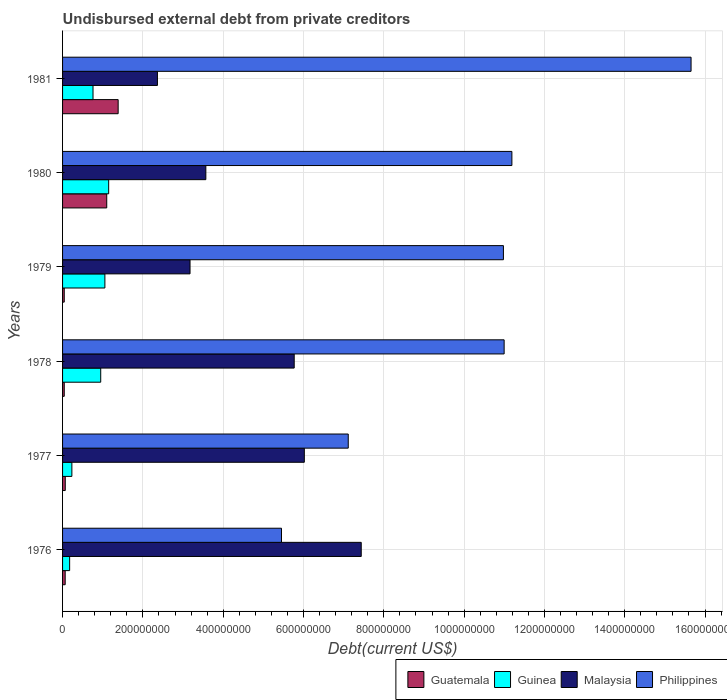Are the number of bars on each tick of the Y-axis equal?
Your response must be concise. Yes. What is the label of the 4th group of bars from the top?
Your answer should be compact. 1978. What is the total debt in Philippines in 1980?
Keep it short and to the point. 1.12e+09. Across all years, what is the maximum total debt in Guinea?
Your answer should be compact. 1.15e+08. Across all years, what is the minimum total debt in Guinea?
Your answer should be compact. 1.76e+07. What is the total total debt in Malaysia in the graph?
Keep it short and to the point. 2.83e+09. What is the difference between the total debt in Malaysia in 1977 and that in 1978?
Your response must be concise. 2.52e+07. What is the difference between the total debt in Guatemala in 1980 and the total debt in Malaysia in 1977?
Ensure brevity in your answer.  -4.92e+08. What is the average total debt in Guinea per year?
Offer a very short reply. 7.20e+07. In the year 1979, what is the difference between the total debt in Malaysia and total debt in Philippines?
Give a very brief answer. -7.80e+08. In how many years, is the total debt in Guatemala greater than 1080000000 US$?
Your answer should be compact. 0. What is the ratio of the total debt in Guatemala in 1976 to that in 1981?
Offer a very short reply. 0.05. Is the total debt in Malaysia in 1976 less than that in 1981?
Your answer should be very brief. No. What is the difference between the highest and the second highest total debt in Philippines?
Provide a short and direct response. 4.46e+08. What is the difference between the highest and the lowest total debt in Guatemala?
Provide a succinct answer. 1.34e+08. In how many years, is the total debt in Guatemala greater than the average total debt in Guatemala taken over all years?
Provide a short and direct response. 2. Is it the case that in every year, the sum of the total debt in Guinea and total debt in Guatemala is greater than the sum of total debt in Philippines and total debt in Malaysia?
Your answer should be very brief. No. What does the 3rd bar from the top in 1980 represents?
Give a very brief answer. Guinea. What does the 3rd bar from the bottom in 1976 represents?
Offer a very short reply. Malaysia. Is it the case that in every year, the sum of the total debt in Malaysia and total debt in Guatemala is greater than the total debt in Philippines?
Offer a very short reply. No. How many bars are there?
Offer a terse response. 24. Does the graph contain grids?
Provide a succinct answer. Yes. How many legend labels are there?
Offer a very short reply. 4. What is the title of the graph?
Provide a succinct answer. Undisbursed external debt from private creditors. Does "Yemen, Rep." appear as one of the legend labels in the graph?
Your response must be concise. No. What is the label or title of the X-axis?
Your response must be concise. Debt(current US$). What is the Debt(current US$) in Guatemala in 1976?
Provide a succinct answer. 6.51e+06. What is the Debt(current US$) of Guinea in 1976?
Offer a very short reply. 1.76e+07. What is the Debt(current US$) of Malaysia in 1976?
Provide a short and direct response. 7.44e+08. What is the Debt(current US$) in Philippines in 1976?
Provide a succinct answer. 5.45e+08. What is the Debt(current US$) in Guatemala in 1977?
Offer a terse response. 6.72e+06. What is the Debt(current US$) of Guinea in 1977?
Give a very brief answer. 2.32e+07. What is the Debt(current US$) in Malaysia in 1977?
Your response must be concise. 6.02e+08. What is the Debt(current US$) of Philippines in 1977?
Keep it short and to the point. 7.11e+08. What is the Debt(current US$) of Guatemala in 1978?
Keep it short and to the point. 4.18e+06. What is the Debt(current US$) in Guinea in 1978?
Give a very brief answer. 9.50e+07. What is the Debt(current US$) in Malaysia in 1978?
Make the answer very short. 5.77e+08. What is the Debt(current US$) of Philippines in 1978?
Keep it short and to the point. 1.10e+09. What is the Debt(current US$) of Guatemala in 1979?
Your answer should be very brief. 4.18e+06. What is the Debt(current US$) of Guinea in 1979?
Ensure brevity in your answer.  1.05e+08. What is the Debt(current US$) in Malaysia in 1979?
Your response must be concise. 3.17e+08. What is the Debt(current US$) of Philippines in 1979?
Give a very brief answer. 1.10e+09. What is the Debt(current US$) of Guatemala in 1980?
Your answer should be compact. 1.10e+08. What is the Debt(current US$) of Guinea in 1980?
Offer a very short reply. 1.15e+08. What is the Debt(current US$) of Malaysia in 1980?
Your answer should be compact. 3.57e+08. What is the Debt(current US$) in Philippines in 1980?
Offer a terse response. 1.12e+09. What is the Debt(current US$) in Guatemala in 1981?
Your answer should be compact. 1.38e+08. What is the Debt(current US$) in Guinea in 1981?
Provide a succinct answer. 7.58e+07. What is the Debt(current US$) of Malaysia in 1981?
Give a very brief answer. 2.36e+08. What is the Debt(current US$) in Philippines in 1981?
Your response must be concise. 1.57e+09. Across all years, what is the maximum Debt(current US$) of Guatemala?
Offer a terse response. 1.38e+08. Across all years, what is the maximum Debt(current US$) in Guinea?
Your answer should be very brief. 1.15e+08. Across all years, what is the maximum Debt(current US$) of Malaysia?
Your response must be concise. 7.44e+08. Across all years, what is the maximum Debt(current US$) in Philippines?
Offer a very short reply. 1.57e+09. Across all years, what is the minimum Debt(current US$) of Guatemala?
Offer a terse response. 4.18e+06. Across all years, what is the minimum Debt(current US$) of Guinea?
Offer a very short reply. 1.76e+07. Across all years, what is the minimum Debt(current US$) in Malaysia?
Provide a short and direct response. 2.36e+08. Across all years, what is the minimum Debt(current US$) of Philippines?
Your answer should be compact. 5.45e+08. What is the total Debt(current US$) in Guatemala in the graph?
Offer a terse response. 2.70e+08. What is the total Debt(current US$) in Guinea in the graph?
Your response must be concise. 4.32e+08. What is the total Debt(current US$) of Malaysia in the graph?
Provide a succinct answer. 2.83e+09. What is the total Debt(current US$) in Philippines in the graph?
Your response must be concise. 6.14e+09. What is the difference between the Debt(current US$) of Guatemala in 1976 and that in 1977?
Offer a very short reply. -2.15e+05. What is the difference between the Debt(current US$) in Guinea in 1976 and that in 1977?
Keep it short and to the point. -5.54e+06. What is the difference between the Debt(current US$) in Malaysia in 1976 and that in 1977?
Your answer should be compact. 1.42e+08. What is the difference between the Debt(current US$) in Philippines in 1976 and that in 1977?
Your answer should be compact. -1.66e+08. What is the difference between the Debt(current US$) in Guatemala in 1976 and that in 1978?
Provide a succinct answer. 2.34e+06. What is the difference between the Debt(current US$) of Guinea in 1976 and that in 1978?
Provide a short and direct response. -7.74e+07. What is the difference between the Debt(current US$) in Malaysia in 1976 and that in 1978?
Your answer should be compact. 1.67e+08. What is the difference between the Debt(current US$) of Philippines in 1976 and that in 1978?
Your response must be concise. -5.54e+08. What is the difference between the Debt(current US$) of Guatemala in 1976 and that in 1979?
Offer a terse response. 2.34e+06. What is the difference between the Debt(current US$) of Guinea in 1976 and that in 1979?
Your answer should be compact. -8.78e+07. What is the difference between the Debt(current US$) of Malaysia in 1976 and that in 1979?
Ensure brevity in your answer.  4.26e+08. What is the difference between the Debt(current US$) of Philippines in 1976 and that in 1979?
Your response must be concise. -5.53e+08. What is the difference between the Debt(current US$) of Guatemala in 1976 and that in 1980?
Offer a very short reply. -1.03e+08. What is the difference between the Debt(current US$) of Guinea in 1976 and that in 1980?
Ensure brevity in your answer.  -9.72e+07. What is the difference between the Debt(current US$) of Malaysia in 1976 and that in 1980?
Provide a succinct answer. 3.87e+08. What is the difference between the Debt(current US$) in Philippines in 1976 and that in 1980?
Your answer should be compact. -5.74e+08. What is the difference between the Debt(current US$) of Guatemala in 1976 and that in 1981?
Provide a succinct answer. -1.32e+08. What is the difference between the Debt(current US$) of Guinea in 1976 and that in 1981?
Provide a succinct answer. -5.82e+07. What is the difference between the Debt(current US$) of Malaysia in 1976 and that in 1981?
Ensure brevity in your answer.  5.08e+08. What is the difference between the Debt(current US$) in Philippines in 1976 and that in 1981?
Your answer should be compact. -1.02e+09. What is the difference between the Debt(current US$) of Guatemala in 1977 and that in 1978?
Give a very brief answer. 2.55e+06. What is the difference between the Debt(current US$) in Guinea in 1977 and that in 1978?
Offer a terse response. -7.18e+07. What is the difference between the Debt(current US$) in Malaysia in 1977 and that in 1978?
Offer a very short reply. 2.52e+07. What is the difference between the Debt(current US$) of Philippines in 1977 and that in 1978?
Provide a short and direct response. -3.88e+08. What is the difference between the Debt(current US$) in Guatemala in 1977 and that in 1979?
Your answer should be very brief. 2.55e+06. What is the difference between the Debt(current US$) in Guinea in 1977 and that in 1979?
Ensure brevity in your answer.  -8.22e+07. What is the difference between the Debt(current US$) in Malaysia in 1977 and that in 1979?
Your answer should be very brief. 2.85e+08. What is the difference between the Debt(current US$) of Philippines in 1977 and that in 1979?
Provide a succinct answer. -3.86e+08. What is the difference between the Debt(current US$) of Guatemala in 1977 and that in 1980?
Make the answer very short. -1.03e+08. What is the difference between the Debt(current US$) of Guinea in 1977 and that in 1980?
Ensure brevity in your answer.  -9.16e+07. What is the difference between the Debt(current US$) in Malaysia in 1977 and that in 1980?
Your answer should be very brief. 2.45e+08. What is the difference between the Debt(current US$) in Philippines in 1977 and that in 1980?
Keep it short and to the point. -4.08e+08. What is the difference between the Debt(current US$) in Guatemala in 1977 and that in 1981?
Your answer should be very brief. -1.32e+08. What is the difference between the Debt(current US$) in Guinea in 1977 and that in 1981?
Offer a very short reply. -5.27e+07. What is the difference between the Debt(current US$) in Malaysia in 1977 and that in 1981?
Keep it short and to the point. 3.66e+08. What is the difference between the Debt(current US$) of Philippines in 1977 and that in 1981?
Provide a short and direct response. -8.54e+08. What is the difference between the Debt(current US$) of Guatemala in 1978 and that in 1979?
Keep it short and to the point. 0. What is the difference between the Debt(current US$) of Guinea in 1978 and that in 1979?
Your answer should be very brief. -1.04e+07. What is the difference between the Debt(current US$) of Malaysia in 1978 and that in 1979?
Ensure brevity in your answer.  2.59e+08. What is the difference between the Debt(current US$) of Philippines in 1978 and that in 1979?
Keep it short and to the point. 1.78e+06. What is the difference between the Debt(current US$) in Guatemala in 1978 and that in 1980?
Your answer should be compact. -1.06e+08. What is the difference between the Debt(current US$) in Guinea in 1978 and that in 1980?
Give a very brief answer. -1.98e+07. What is the difference between the Debt(current US$) in Malaysia in 1978 and that in 1980?
Ensure brevity in your answer.  2.20e+08. What is the difference between the Debt(current US$) in Philippines in 1978 and that in 1980?
Offer a terse response. -1.93e+07. What is the difference between the Debt(current US$) of Guatemala in 1978 and that in 1981?
Ensure brevity in your answer.  -1.34e+08. What is the difference between the Debt(current US$) in Guinea in 1978 and that in 1981?
Your answer should be very brief. 1.92e+07. What is the difference between the Debt(current US$) in Malaysia in 1978 and that in 1981?
Your answer should be very brief. 3.41e+08. What is the difference between the Debt(current US$) in Philippines in 1978 and that in 1981?
Make the answer very short. -4.66e+08. What is the difference between the Debt(current US$) of Guatemala in 1979 and that in 1980?
Keep it short and to the point. -1.06e+08. What is the difference between the Debt(current US$) of Guinea in 1979 and that in 1980?
Provide a succinct answer. -9.43e+06. What is the difference between the Debt(current US$) of Malaysia in 1979 and that in 1980?
Offer a terse response. -3.94e+07. What is the difference between the Debt(current US$) in Philippines in 1979 and that in 1980?
Keep it short and to the point. -2.11e+07. What is the difference between the Debt(current US$) of Guatemala in 1979 and that in 1981?
Your answer should be very brief. -1.34e+08. What is the difference between the Debt(current US$) of Guinea in 1979 and that in 1981?
Offer a terse response. 2.96e+07. What is the difference between the Debt(current US$) of Malaysia in 1979 and that in 1981?
Your answer should be compact. 8.12e+07. What is the difference between the Debt(current US$) of Philippines in 1979 and that in 1981?
Keep it short and to the point. -4.67e+08. What is the difference between the Debt(current US$) in Guatemala in 1980 and that in 1981?
Offer a terse response. -2.84e+07. What is the difference between the Debt(current US$) in Guinea in 1980 and that in 1981?
Make the answer very short. 3.90e+07. What is the difference between the Debt(current US$) of Malaysia in 1980 and that in 1981?
Provide a short and direct response. 1.21e+08. What is the difference between the Debt(current US$) in Philippines in 1980 and that in 1981?
Ensure brevity in your answer.  -4.46e+08. What is the difference between the Debt(current US$) in Guatemala in 1976 and the Debt(current US$) in Guinea in 1977?
Offer a terse response. -1.67e+07. What is the difference between the Debt(current US$) in Guatemala in 1976 and the Debt(current US$) in Malaysia in 1977?
Your answer should be very brief. -5.96e+08. What is the difference between the Debt(current US$) of Guatemala in 1976 and the Debt(current US$) of Philippines in 1977?
Make the answer very short. -7.05e+08. What is the difference between the Debt(current US$) of Guinea in 1976 and the Debt(current US$) of Malaysia in 1977?
Make the answer very short. -5.84e+08. What is the difference between the Debt(current US$) in Guinea in 1976 and the Debt(current US$) in Philippines in 1977?
Provide a short and direct response. -6.94e+08. What is the difference between the Debt(current US$) of Malaysia in 1976 and the Debt(current US$) of Philippines in 1977?
Make the answer very short. 3.24e+07. What is the difference between the Debt(current US$) of Guatemala in 1976 and the Debt(current US$) of Guinea in 1978?
Make the answer very short. -8.85e+07. What is the difference between the Debt(current US$) of Guatemala in 1976 and the Debt(current US$) of Malaysia in 1978?
Your response must be concise. -5.70e+08. What is the difference between the Debt(current US$) in Guatemala in 1976 and the Debt(current US$) in Philippines in 1978?
Your answer should be compact. -1.09e+09. What is the difference between the Debt(current US$) of Guinea in 1976 and the Debt(current US$) of Malaysia in 1978?
Your answer should be very brief. -5.59e+08. What is the difference between the Debt(current US$) of Guinea in 1976 and the Debt(current US$) of Philippines in 1978?
Give a very brief answer. -1.08e+09. What is the difference between the Debt(current US$) of Malaysia in 1976 and the Debt(current US$) of Philippines in 1978?
Your answer should be compact. -3.56e+08. What is the difference between the Debt(current US$) of Guatemala in 1976 and the Debt(current US$) of Guinea in 1979?
Your answer should be very brief. -9.89e+07. What is the difference between the Debt(current US$) of Guatemala in 1976 and the Debt(current US$) of Malaysia in 1979?
Provide a succinct answer. -3.11e+08. What is the difference between the Debt(current US$) in Guatemala in 1976 and the Debt(current US$) in Philippines in 1979?
Ensure brevity in your answer.  -1.09e+09. What is the difference between the Debt(current US$) of Guinea in 1976 and the Debt(current US$) of Malaysia in 1979?
Provide a short and direct response. -3.00e+08. What is the difference between the Debt(current US$) in Guinea in 1976 and the Debt(current US$) in Philippines in 1979?
Provide a succinct answer. -1.08e+09. What is the difference between the Debt(current US$) of Malaysia in 1976 and the Debt(current US$) of Philippines in 1979?
Provide a short and direct response. -3.54e+08. What is the difference between the Debt(current US$) of Guatemala in 1976 and the Debt(current US$) of Guinea in 1980?
Your answer should be very brief. -1.08e+08. What is the difference between the Debt(current US$) in Guatemala in 1976 and the Debt(current US$) in Malaysia in 1980?
Provide a short and direct response. -3.50e+08. What is the difference between the Debt(current US$) of Guatemala in 1976 and the Debt(current US$) of Philippines in 1980?
Give a very brief answer. -1.11e+09. What is the difference between the Debt(current US$) of Guinea in 1976 and the Debt(current US$) of Malaysia in 1980?
Give a very brief answer. -3.39e+08. What is the difference between the Debt(current US$) in Guinea in 1976 and the Debt(current US$) in Philippines in 1980?
Keep it short and to the point. -1.10e+09. What is the difference between the Debt(current US$) in Malaysia in 1976 and the Debt(current US$) in Philippines in 1980?
Your answer should be very brief. -3.75e+08. What is the difference between the Debt(current US$) in Guatemala in 1976 and the Debt(current US$) in Guinea in 1981?
Your answer should be very brief. -6.93e+07. What is the difference between the Debt(current US$) in Guatemala in 1976 and the Debt(current US$) in Malaysia in 1981?
Your answer should be very brief. -2.30e+08. What is the difference between the Debt(current US$) in Guatemala in 1976 and the Debt(current US$) in Philippines in 1981?
Make the answer very short. -1.56e+09. What is the difference between the Debt(current US$) of Guinea in 1976 and the Debt(current US$) of Malaysia in 1981?
Make the answer very short. -2.19e+08. What is the difference between the Debt(current US$) of Guinea in 1976 and the Debt(current US$) of Philippines in 1981?
Give a very brief answer. -1.55e+09. What is the difference between the Debt(current US$) of Malaysia in 1976 and the Debt(current US$) of Philippines in 1981?
Offer a terse response. -8.21e+08. What is the difference between the Debt(current US$) in Guatemala in 1977 and the Debt(current US$) in Guinea in 1978?
Your answer should be very brief. -8.83e+07. What is the difference between the Debt(current US$) in Guatemala in 1977 and the Debt(current US$) in Malaysia in 1978?
Your answer should be very brief. -5.70e+08. What is the difference between the Debt(current US$) of Guatemala in 1977 and the Debt(current US$) of Philippines in 1978?
Make the answer very short. -1.09e+09. What is the difference between the Debt(current US$) of Guinea in 1977 and the Debt(current US$) of Malaysia in 1978?
Your answer should be very brief. -5.54e+08. What is the difference between the Debt(current US$) in Guinea in 1977 and the Debt(current US$) in Philippines in 1978?
Offer a terse response. -1.08e+09. What is the difference between the Debt(current US$) of Malaysia in 1977 and the Debt(current US$) of Philippines in 1978?
Give a very brief answer. -4.98e+08. What is the difference between the Debt(current US$) of Guatemala in 1977 and the Debt(current US$) of Guinea in 1979?
Provide a short and direct response. -9.87e+07. What is the difference between the Debt(current US$) in Guatemala in 1977 and the Debt(current US$) in Malaysia in 1979?
Offer a terse response. -3.11e+08. What is the difference between the Debt(current US$) in Guatemala in 1977 and the Debt(current US$) in Philippines in 1979?
Your answer should be very brief. -1.09e+09. What is the difference between the Debt(current US$) in Guinea in 1977 and the Debt(current US$) in Malaysia in 1979?
Your answer should be compact. -2.94e+08. What is the difference between the Debt(current US$) of Guinea in 1977 and the Debt(current US$) of Philippines in 1979?
Provide a short and direct response. -1.07e+09. What is the difference between the Debt(current US$) in Malaysia in 1977 and the Debt(current US$) in Philippines in 1979?
Give a very brief answer. -4.96e+08. What is the difference between the Debt(current US$) of Guatemala in 1977 and the Debt(current US$) of Guinea in 1980?
Keep it short and to the point. -1.08e+08. What is the difference between the Debt(current US$) in Guatemala in 1977 and the Debt(current US$) in Malaysia in 1980?
Offer a terse response. -3.50e+08. What is the difference between the Debt(current US$) in Guatemala in 1977 and the Debt(current US$) in Philippines in 1980?
Your answer should be very brief. -1.11e+09. What is the difference between the Debt(current US$) of Guinea in 1977 and the Debt(current US$) of Malaysia in 1980?
Provide a succinct answer. -3.34e+08. What is the difference between the Debt(current US$) of Guinea in 1977 and the Debt(current US$) of Philippines in 1980?
Give a very brief answer. -1.10e+09. What is the difference between the Debt(current US$) in Malaysia in 1977 and the Debt(current US$) in Philippines in 1980?
Provide a short and direct response. -5.17e+08. What is the difference between the Debt(current US$) in Guatemala in 1977 and the Debt(current US$) in Guinea in 1981?
Keep it short and to the point. -6.91e+07. What is the difference between the Debt(current US$) of Guatemala in 1977 and the Debt(current US$) of Malaysia in 1981?
Offer a very short reply. -2.30e+08. What is the difference between the Debt(current US$) of Guatemala in 1977 and the Debt(current US$) of Philippines in 1981?
Make the answer very short. -1.56e+09. What is the difference between the Debt(current US$) of Guinea in 1977 and the Debt(current US$) of Malaysia in 1981?
Make the answer very short. -2.13e+08. What is the difference between the Debt(current US$) in Guinea in 1977 and the Debt(current US$) in Philippines in 1981?
Provide a succinct answer. -1.54e+09. What is the difference between the Debt(current US$) in Malaysia in 1977 and the Debt(current US$) in Philippines in 1981?
Keep it short and to the point. -9.63e+08. What is the difference between the Debt(current US$) of Guatemala in 1978 and the Debt(current US$) of Guinea in 1979?
Make the answer very short. -1.01e+08. What is the difference between the Debt(current US$) of Guatemala in 1978 and the Debt(current US$) of Malaysia in 1979?
Offer a terse response. -3.13e+08. What is the difference between the Debt(current US$) in Guatemala in 1978 and the Debt(current US$) in Philippines in 1979?
Provide a short and direct response. -1.09e+09. What is the difference between the Debt(current US$) of Guinea in 1978 and the Debt(current US$) of Malaysia in 1979?
Provide a short and direct response. -2.22e+08. What is the difference between the Debt(current US$) in Guinea in 1978 and the Debt(current US$) in Philippines in 1979?
Make the answer very short. -1.00e+09. What is the difference between the Debt(current US$) of Malaysia in 1978 and the Debt(current US$) of Philippines in 1979?
Offer a very short reply. -5.21e+08. What is the difference between the Debt(current US$) in Guatemala in 1978 and the Debt(current US$) in Guinea in 1980?
Your answer should be compact. -1.11e+08. What is the difference between the Debt(current US$) in Guatemala in 1978 and the Debt(current US$) in Malaysia in 1980?
Ensure brevity in your answer.  -3.53e+08. What is the difference between the Debt(current US$) of Guatemala in 1978 and the Debt(current US$) of Philippines in 1980?
Keep it short and to the point. -1.11e+09. What is the difference between the Debt(current US$) of Guinea in 1978 and the Debt(current US$) of Malaysia in 1980?
Ensure brevity in your answer.  -2.62e+08. What is the difference between the Debt(current US$) in Guinea in 1978 and the Debt(current US$) in Philippines in 1980?
Your answer should be compact. -1.02e+09. What is the difference between the Debt(current US$) in Malaysia in 1978 and the Debt(current US$) in Philippines in 1980?
Give a very brief answer. -5.42e+08. What is the difference between the Debt(current US$) of Guatemala in 1978 and the Debt(current US$) of Guinea in 1981?
Offer a terse response. -7.17e+07. What is the difference between the Debt(current US$) in Guatemala in 1978 and the Debt(current US$) in Malaysia in 1981?
Offer a terse response. -2.32e+08. What is the difference between the Debt(current US$) of Guatemala in 1978 and the Debt(current US$) of Philippines in 1981?
Provide a short and direct response. -1.56e+09. What is the difference between the Debt(current US$) of Guinea in 1978 and the Debt(current US$) of Malaysia in 1981?
Keep it short and to the point. -1.41e+08. What is the difference between the Debt(current US$) in Guinea in 1978 and the Debt(current US$) in Philippines in 1981?
Ensure brevity in your answer.  -1.47e+09. What is the difference between the Debt(current US$) in Malaysia in 1978 and the Debt(current US$) in Philippines in 1981?
Your response must be concise. -9.88e+08. What is the difference between the Debt(current US$) in Guatemala in 1979 and the Debt(current US$) in Guinea in 1980?
Offer a terse response. -1.11e+08. What is the difference between the Debt(current US$) of Guatemala in 1979 and the Debt(current US$) of Malaysia in 1980?
Ensure brevity in your answer.  -3.53e+08. What is the difference between the Debt(current US$) of Guatemala in 1979 and the Debt(current US$) of Philippines in 1980?
Keep it short and to the point. -1.11e+09. What is the difference between the Debt(current US$) in Guinea in 1979 and the Debt(current US$) in Malaysia in 1980?
Your answer should be compact. -2.51e+08. What is the difference between the Debt(current US$) of Guinea in 1979 and the Debt(current US$) of Philippines in 1980?
Your answer should be very brief. -1.01e+09. What is the difference between the Debt(current US$) in Malaysia in 1979 and the Debt(current US$) in Philippines in 1980?
Give a very brief answer. -8.02e+08. What is the difference between the Debt(current US$) in Guatemala in 1979 and the Debt(current US$) in Guinea in 1981?
Ensure brevity in your answer.  -7.17e+07. What is the difference between the Debt(current US$) in Guatemala in 1979 and the Debt(current US$) in Malaysia in 1981?
Make the answer very short. -2.32e+08. What is the difference between the Debt(current US$) of Guatemala in 1979 and the Debt(current US$) of Philippines in 1981?
Your answer should be compact. -1.56e+09. What is the difference between the Debt(current US$) of Guinea in 1979 and the Debt(current US$) of Malaysia in 1981?
Offer a terse response. -1.31e+08. What is the difference between the Debt(current US$) in Guinea in 1979 and the Debt(current US$) in Philippines in 1981?
Keep it short and to the point. -1.46e+09. What is the difference between the Debt(current US$) of Malaysia in 1979 and the Debt(current US$) of Philippines in 1981?
Provide a succinct answer. -1.25e+09. What is the difference between the Debt(current US$) in Guatemala in 1980 and the Debt(current US$) in Guinea in 1981?
Keep it short and to the point. 3.42e+07. What is the difference between the Debt(current US$) of Guatemala in 1980 and the Debt(current US$) of Malaysia in 1981?
Provide a short and direct response. -1.26e+08. What is the difference between the Debt(current US$) of Guatemala in 1980 and the Debt(current US$) of Philippines in 1981?
Ensure brevity in your answer.  -1.46e+09. What is the difference between the Debt(current US$) of Guinea in 1980 and the Debt(current US$) of Malaysia in 1981?
Your answer should be compact. -1.21e+08. What is the difference between the Debt(current US$) in Guinea in 1980 and the Debt(current US$) in Philippines in 1981?
Offer a very short reply. -1.45e+09. What is the difference between the Debt(current US$) of Malaysia in 1980 and the Debt(current US$) of Philippines in 1981?
Your answer should be compact. -1.21e+09. What is the average Debt(current US$) of Guatemala per year?
Your answer should be compact. 4.50e+07. What is the average Debt(current US$) of Guinea per year?
Offer a very short reply. 7.20e+07. What is the average Debt(current US$) of Malaysia per year?
Keep it short and to the point. 4.72e+08. What is the average Debt(current US$) in Philippines per year?
Make the answer very short. 1.02e+09. In the year 1976, what is the difference between the Debt(current US$) of Guatemala and Debt(current US$) of Guinea?
Your answer should be compact. -1.11e+07. In the year 1976, what is the difference between the Debt(current US$) in Guatemala and Debt(current US$) in Malaysia?
Provide a succinct answer. -7.37e+08. In the year 1976, what is the difference between the Debt(current US$) in Guatemala and Debt(current US$) in Philippines?
Provide a short and direct response. -5.39e+08. In the year 1976, what is the difference between the Debt(current US$) of Guinea and Debt(current US$) of Malaysia?
Provide a short and direct response. -7.26e+08. In the year 1976, what is the difference between the Debt(current US$) of Guinea and Debt(current US$) of Philippines?
Offer a very short reply. -5.28e+08. In the year 1976, what is the difference between the Debt(current US$) of Malaysia and Debt(current US$) of Philippines?
Your response must be concise. 1.99e+08. In the year 1977, what is the difference between the Debt(current US$) in Guatemala and Debt(current US$) in Guinea?
Keep it short and to the point. -1.65e+07. In the year 1977, what is the difference between the Debt(current US$) of Guatemala and Debt(current US$) of Malaysia?
Your response must be concise. -5.95e+08. In the year 1977, what is the difference between the Debt(current US$) in Guatemala and Debt(current US$) in Philippines?
Offer a terse response. -7.05e+08. In the year 1977, what is the difference between the Debt(current US$) in Guinea and Debt(current US$) in Malaysia?
Your answer should be compact. -5.79e+08. In the year 1977, what is the difference between the Debt(current US$) in Guinea and Debt(current US$) in Philippines?
Ensure brevity in your answer.  -6.88e+08. In the year 1977, what is the difference between the Debt(current US$) in Malaysia and Debt(current US$) in Philippines?
Keep it short and to the point. -1.09e+08. In the year 1978, what is the difference between the Debt(current US$) of Guatemala and Debt(current US$) of Guinea?
Provide a succinct answer. -9.08e+07. In the year 1978, what is the difference between the Debt(current US$) in Guatemala and Debt(current US$) in Malaysia?
Offer a very short reply. -5.73e+08. In the year 1978, what is the difference between the Debt(current US$) of Guatemala and Debt(current US$) of Philippines?
Offer a very short reply. -1.10e+09. In the year 1978, what is the difference between the Debt(current US$) of Guinea and Debt(current US$) of Malaysia?
Your answer should be very brief. -4.82e+08. In the year 1978, what is the difference between the Debt(current US$) of Guinea and Debt(current US$) of Philippines?
Keep it short and to the point. -1.00e+09. In the year 1978, what is the difference between the Debt(current US$) of Malaysia and Debt(current US$) of Philippines?
Your response must be concise. -5.23e+08. In the year 1979, what is the difference between the Debt(current US$) of Guatemala and Debt(current US$) of Guinea?
Offer a very short reply. -1.01e+08. In the year 1979, what is the difference between the Debt(current US$) of Guatemala and Debt(current US$) of Malaysia?
Your answer should be very brief. -3.13e+08. In the year 1979, what is the difference between the Debt(current US$) of Guatemala and Debt(current US$) of Philippines?
Offer a terse response. -1.09e+09. In the year 1979, what is the difference between the Debt(current US$) of Guinea and Debt(current US$) of Malaysia?
Provide a short and direct response. -2.12e+08. In the year 1979, what is the difference between the Debt(current US$) of Guinea and Debt(current US$) of Philippines?
Offer a very short reply. -9.92e+08. In the year 1979, what is the difference between the Debt(current US$) of Malaysia and Debt(current US$) of Philippines?
Provide a succinct answer. -7.80e+08. In the year 1980, what is the difference between the Debt(current US$) in Guatemala and Debt(current US$) in Guinea?
Give a very brief answer. -4.82e+06. In the year 1980, what is the difference between the Debt(current US$) of Guatemala and Debt(current US$) of Malaysia?
Your answer should be compact. -2.47e+08. In the year 1980, what is the difference between the Debt(current US$) in Guatemala and Debt(current US$) in Philippines?
Your answer should be compact. -1.01e+09. In the year 1980, what is the difference between the Debt(current US$) in Guinea and Debt(current US$) in Malaysia?
Give a very brief answer. -2.42e+08. In the year 1980, what is the difference between the Debt(current US$) of Guinea and Debt(current US$) of Philippines?
Provide a succinct answer. -1.00e+09. In the year 1980, what is the difference between the Debt(current US$) of Malaysia and Debt(current US$) of Philippines?
Keep it short and to the point. -7.62e+08. In the year 1981, what is the difference between the Debt(current US$) in Guatemala and Debt(current US$) in Guinea?
Your answer should be compact. 6.26e+07. In the year 1981, what is the difference between the Debt(current US$) in Guatemala and Debt(current US$) in Malaysia?
Make the answer very short. -9.78e+07. In the year 1981, what is the difference between the Debt(current US$) in Guatemala and Debt(current US$) in Philippines?
Your answer should be compact. -1.43e+09. In the year 1981, what is the difference between the Debt(current US$) of Guinea and Debt(current US$) of Malaysia?
Give a very brief answer. -1.60e+08. In the year 1981, what is the difference between the Debt(current US$) of Guinea and Debt(current US$) of Philippines?
Ensure brevity in your answer.  -1.49e+09. In the year 1981, what is the difference between the Debt(current US$) in Malaysia and Debt(current US$) in Philippines?
Keep it short and to the point. -1.33e+09. What is the ratio of the Debt(current US$) of Guatemala in 1976 to that in 1977?
Your answer should be very brief. 0.97. What is the ratio of the Debt(current US$) of Guinea in 1976 to that in 1977?
Give a very brief answer. 0.76. What is the ratio of the Debt(current US$) of Malaysia in 1976 to that in 1977?
Provide a short and direct response. 1.24. What is the ratio of the Debt(current US$) of Philippines in 1976 to that in 1977?
Your response must be concise. 0.77. What is the ratio of the Debt(current US$) of Guatemala in 1976 to that in 1978?
Offer a terse response. 1.56. What is the ratio of the Debt(current US$) of Guinea in 1976 to that in 1978?
Your answer should be very brief. 0.19. What is the ratio of the Debt(current US$) in Malaysia in 1976 to that in 1978?
Your answer should be very brief. 1.29. What is the ratio of the Debt(current US$) in Philippines in 1976 to that in 1978?
Keep it short and to the point. 0.5. What is the ratio of the Debt(current US$) of Guatemala in 1976 to that in 1979?
Your answer should be compact. 1.56. What is the ratio of the Debt(current US$) in Guinea in 1976 to that in 1979?
Your answer should be compact. 0.17. What is the ratio of the Debt(current US$) in Malaysia in 1976 to that in 1979?
Offer a very short reply. 2.34. What is the ratio of the Debt(current US$) in Philippines in 1976 to that in 1979?
Provide a short and direct response. 0.5. What is the ratio of the Debt(current US$) of Guatemala in 1976 to that in 1980?
Offer a terse response. 0.06. What is the ratio of the Debt(current US$) of Guinea in 1976 to that in 1980?
Give a very brief answer. 0.15. What is the ratio of the Debt(current US$) of Malaysia in 1976 to that in 1980?
Your answer should be compact. 2.08. What is the ratio of the Debt(current US$) in Philippines in 1976 to that in 1980?
Your response must be concise. 0.49. What is the ratio of the Debt(current US$) of Guatemala in 1976 to that in 1981?
Give a very brief answer. 0.05. What is the ratio of the Debt(current US$) of Guinea in 1976 to that in 1981?
Your answer should be very brief. 0.23. What is the ratio of the Debt(current US$) in Malaysia in 1976 to that in 1981?
Provide a succinct answer. 3.15. What is the ratio of the Debt(current US$) of Philippines in 1976 to that in 1981?
Your answer should be compact. 0.35. What is the ratio of the Debt(current US$) of Guatemala in 1977 to that in 1978?
Provide a succinct answer. 1.61. What is the ratio of the Debt(current US$) of Guinea in 1977 to that in 1978?
Your answer should be compact. 0.24. What is the ratio of the Debt(current US$) of Malaysia in 1977 to that in 1978?
Keep it short and to the point. 1.04. What is the ratio of the Debt(current US$) of Philippines in 1977 to that in 1978?
Ensure brevity in your answer.  0.65. What is the ratio of the Debt(current US$) of Guatemala in 1977 to that in 1979?
Provide a short and direct response. 1.61. What is the ratio of the Debt(current US$) of Guinea in 1977 to that in 1979?
Offer a very short reply. 0.22. What is the ratio of the Debt(current US$) in Malaysia in 1977 to that in 1979?
Provide a short and direct response. 1.9. What is the ratio of the Debt(current US$) of Philippines in 1977 to that in 1979?
Make the answer very short. 0.65. What is the ratio of the Debt(current US$) of Guatemala in 1977 to that in 1980?
Provide a short and direct response. 0.06. What is the ratio of the Debt(current US$) in Guinea in 1977 to that in 1980?
Your answer should be compact. 0.2. What is the ratio of the Debt(current US$) in Malaysia in 1977 to that in 1980?
Keep it short and to the point. 1.69. What is the ratio of the Debt(current US$) in Philippines in 1977 to that in 1980?
Give a very brief answer. 0.64. What is the ratio of the Debt(current US$) in Guatemala in 1977 to that in 1981?
Give a very brief answer. 0.05. What is the ratio of the Debt(current US$) in Guinea in 1977 to that in 1981?
Your answer should be compact. 0.31. What is the ratio of the Debt(current US$) in Malaysia in 1977 to that in 1981?
Provide a short and direct response. 2.55. What is the ratio of the Debt(current US$) of Philippines in 1977 to that in 1981?
Your answer should be compact. 0.45. What is the ratio of the Debt(current US$) in Guatemala in 1978 to that in 1979?
Provide a short and direct response. 1. What is the ratio of the Debt(current US$) in Guinea in 1978 to that in 1979?
Offer a very short reply. 0.9. What is the ratio of the Debt(current US$) in Malaysia in 1978 to that in 1979?
Provide a short and direct response. 1.82. What is the ratio of the Debt(current US$) of Philippines in 1978 to that in 1979?
Your answer should be very brief. 1. What is the ratio of the Debt(current US$) in Guatemala in 1978 to that in 1980?
Your answer should be very brief. 0.04. What is the ratio of the Debt(current US$) in Guinea in 1978 to that in 1980?
Your answer should be compact. 0.83. What is the ratio of the Debt(current US$) of Malaysia in 1978 to that in 1980?
Keep it short and to the point. 1.62. What is the ratio of the Debt(current US$) of Philippines in 1978 to that in 1980?
Your answer should be very brief. 0.98. What is the ratio of the Debt(current US$) of Guatemala in 1978 to that in 1981?
Your answer should be very brief. 0.03. What is the ratio of the Debt(current US$) in Guinea in 1978 to that in 1981?
Give a very brief answer. 1.25. What is the ratio of the Debt(current US$) of Malaysia in 1978 to that in 1981?
Provide a succinct answer. 2.44. What is the ratio of the Debt(current US$) in Philippines in 1978 to that in 1981?
Your answer should be compact. 0.7. What is the ratio of the Debt(current US$) of Guatemala in 1979 to that in 1980?
Your answer should be very brief. 0.04. What is the ratio of the Debt(current US$) of Guinea in 1979 to that in 1980?
Your answer should be compact. 0.92. What is the ratio of the Debt(current US$) of Malaysia in 1979 to that in 1980?
Your response must be concise. 0.89. What is the ratio of the Debt(current US$) in Philippines in 1979 to that in 1980?
Offer a terse response. 0.98. What is the ratio of the Debt(current US$) of Guatemala in 1979 to that in 1981?
Provide a short and direct response. 0.03. What is the ratio of the Debt(current US$) of Guinea in 1979 to that in 1981?
Ensure brevity in your answer.  1.39. What is the ratio of the Debt(current US$) in Malaysia in 1979 to that in 1981?
Your answer should be compact. 1.34. What is the ratio of the Debt(current US$) of Philippines in 1979 to that in 1981?
Your response must be concise. 0.7. What is the ratio of the Debt(current US$) of Guatemala in 1980 to that in 1981?
Offer a very short reply. 0.79. What is the ratio of the Debt(current US$) of Guinea in 1980 to that in 1981?
Make the answer very short. 1.51. What is the ratio of the Debt(current US$) of Malaysia in 1980 to that in 1981?
Give a very brief answer. 1.51. What is the ratio of the Debt(current US$) of Philippines in 1980 to that in 1981?
Provide a succinct answer. 0.71. What is the difference between the highest and the second highest Debt(current US$) of Guatemala?
Make the answer very short. 2.84e+07. What is the difference between the highest and the second highest Debt(current US$) in Guinea?
Your answer should be very brief. 9.43e+06. What is the difference between the highest and the second highest Debt(current US$) of Malaysia?
Your answer should be compact. 1.42e+08. What is the difference between the highest and the second highest Debt(current US$) in Philippines?
Provide a succinct answer. 4.46e+08. What is the difference between the highest and the lowest Debt(current US$) in Guatemala?
Your answer should be compact. 1.34e+08. What is the difference between the highest and the lowest Debt(current US$) of Guinea?
Provide a short and direct response. 9.72e+07. What is the difference between the highest and the lowest Debt(current US$) of Malaysia?
Offer a terse response. 5.08e+08. What is the difference between the highest and the lowest Debt(current US$) in Philippines?
Provide a succinct answer. 1.02e+09. 